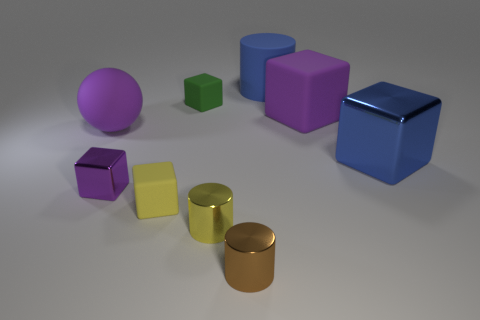What material is the large object that is the same color as the large rubber cylinder?
Keep it short and to the point. Metal. Are there any big purple objects of the same shape as the small brown object?
Offer a terse response. No. There is a purple cube that is to the right of the tiny yellow rubber cube; what size is it?
Your response must be concise. Large. There is a purple sphere that is the same size as the blue metallic object; what is its material?
Make the answer very short. Rubber. Are there more blue rubber objects than big yellow matte cubes?
Provide a succinct answer. Yes. How big is the shiny thing that is to the right of the small metal object in front of the small yellow metallic thing?
Provide a succinct answer. Large. What shape is the purple object that is the same size as the green object?
Make the answer very short. Cube. What shape is the purple rubber object that is to the right of the small yellow cylinder that is in front of the purple cube that is right of the big blue matte cylinder?
Your response must be concise. Cube. Does the big matte object on the left side of the tiny purple block have the same color as the metallic thing to the left of the green matte thing?
Offer a terse response. Yes. How many blocks are there?
Your response must be concise. 5. 